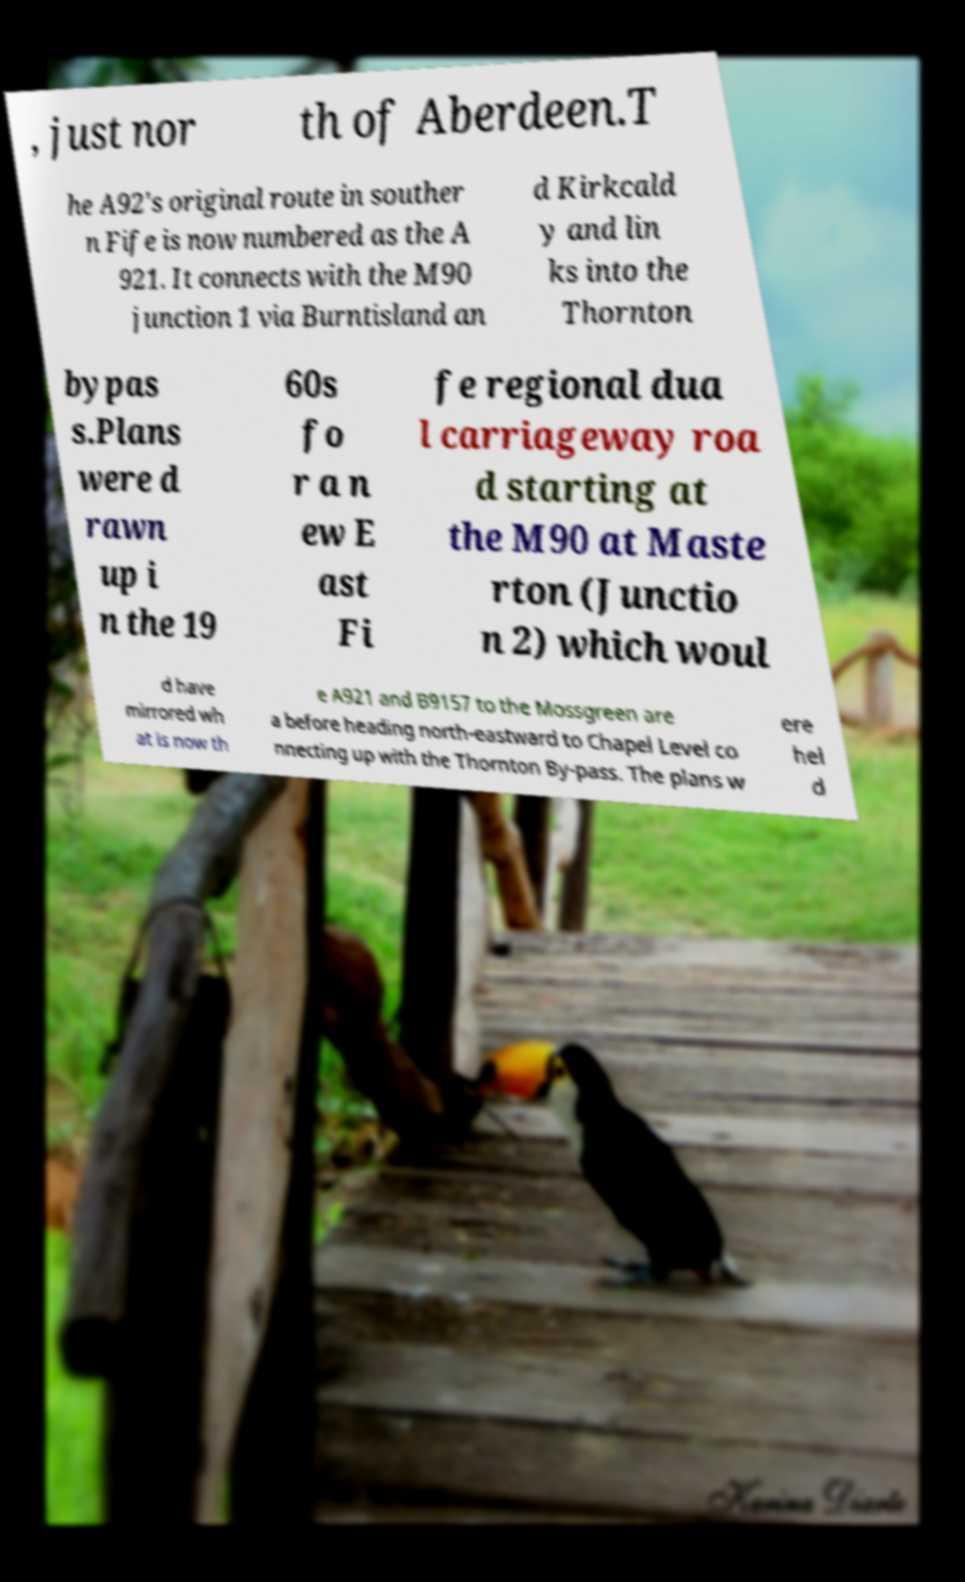What messages or text are displayed in this image? I need them in a readable, typed format. , just nor th of Aberdeen.T he A92's original route in souther n Fife is now numbered as the A 921. It connects with the M90 junction 1 via Burntisland an d Kirkcald y and lin ks into the Thornton bypas s.Plans were d rawn up i n the 19 60s fo r a n ew E ast Fi fe regional dua l carriageway roa d starting at the M90 at Maste rton (Junctio n 2) which woul d have mirrored wh at is now th e A921 and B9157 to the Mossgreen are a before heading north-eastward to Chapel Level co nnecting up with the Thornton By-pass. The plans w ere hel d 